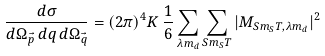Convert formula to latex. <formula><loc_0><loc_0><loc_500><loc_500>\frac { d \sigma } { d \Omega _ { \vec { p } } \, d q \, d \Omega _ { \vec { q } } } = { ( 2 \pi ) ^ { 4 } } { K } \, \frac { 1 } { 6 } \sum _ { \lambda m _ { d } } \sum _ { S m _ { S } T } | M _ { S m _ { S } T , \lambda m _ { d } } | ^ { 2 } \</formula> 